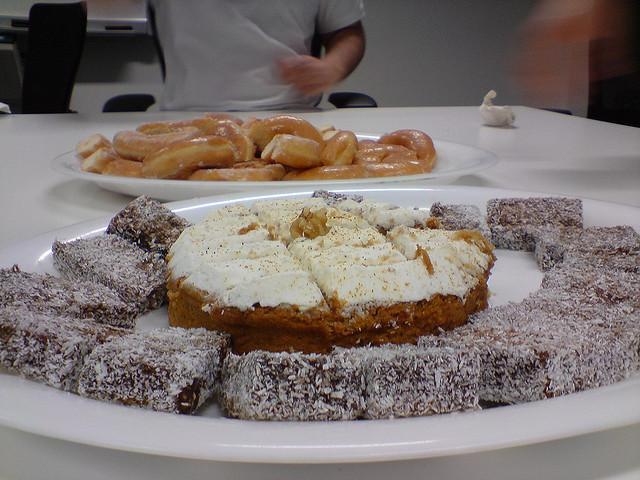How many plates are there?
Give a very brief answer. 2. How many chairs are there?
Give a very brief answer. 2. How many cakes are there?
Give a very brief answer. 6. How many keyboards are in the picture?
Give a very brief answer. 0. 